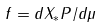<formula> <loc_0><loc_0><loc_500><loc_500>f = d X _ { * } P / d \mu</formula> 